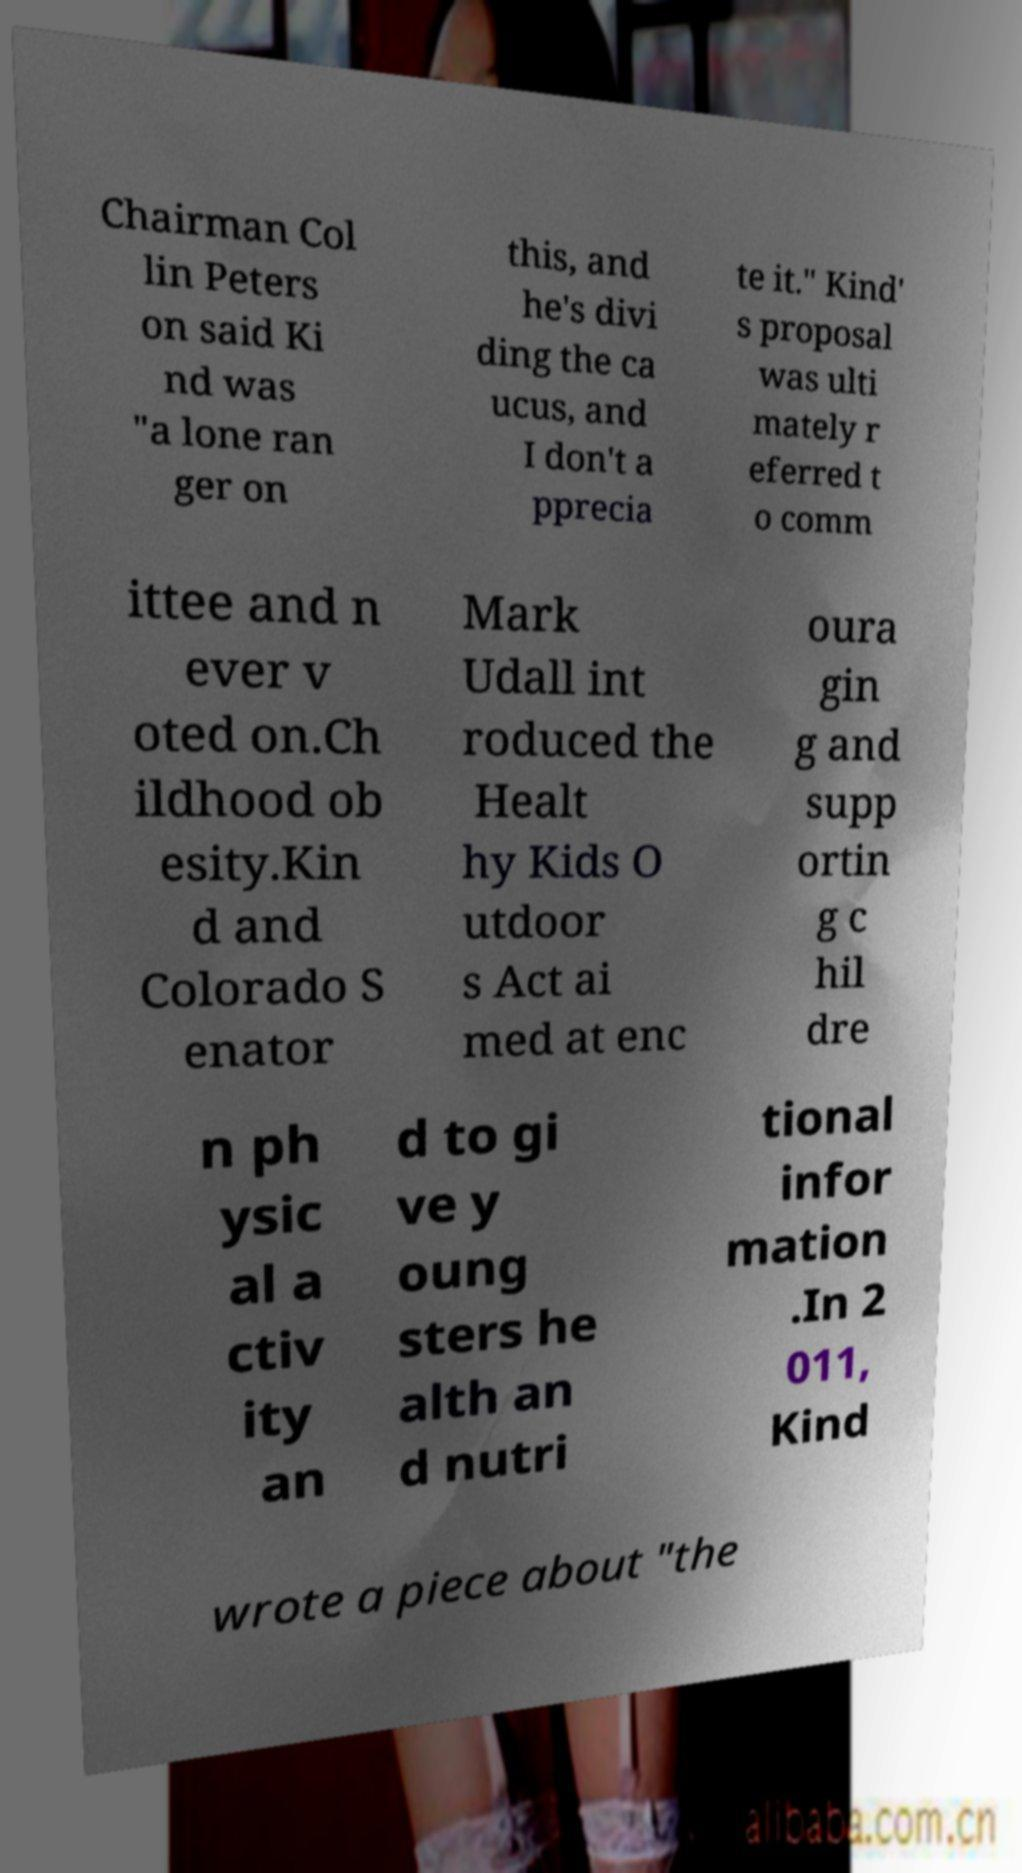Can you accurately transcribe the text from the provided image for me? Chairman Col lin Peters on said Ki nd was "a lone ran ger on this, and he's divi ding the ca ucus, and I don't a pprecia te it." Kind' s proposal was ulti mately r eferred t o comm ittee and n ever v oted on.Ch ildhood ob esity.Kin d and Colorado S enator Mark Udall int roduced the Healt hy Kids O utdoor s Act ai med at enc oura gin g and supp ortin g c hil dre n ph ysic al a ctiv ity an d to gi ve y oung sters he alth an d nutri tional infor mation .In 2 011, Kind wrote a piece about "the 